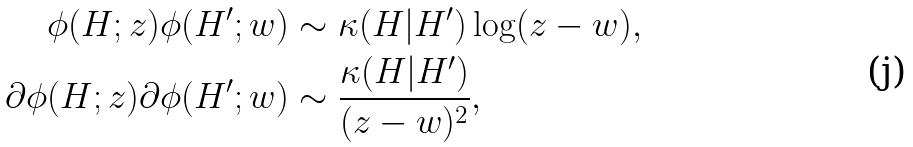<formula> <loc_0><loc_0><loc_500><loc_500>\phi ( H ; z ) \phi ( H ^ { \prime } ; w ) & \sim \kappa ( H | H ^ { \prime } ) \log ( z - w ) , \\ \partial \phi ( H ; z ) \partial \phi ( H ^ { \prime } ; w ) & \sim \frac { \kappa ( H | H ^ { \prime } ) } { ( z - w ) ^ { 2 } } ,</formula> 